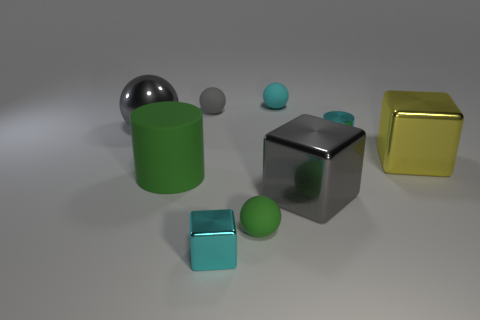There is a gray object that is both on the right side of the big green object and behind the yellow shiny cube; what is it made of?
Your answer should be very brief. Rubber. Is the number of cylinders behind the green cylinder greater than the number of big green things that are on the left side of the large gray ball?
Your response must be concise. Yes. Is there a matte cylinder of the same size as the gray shiny block?
Ensure brevity in your answer.  Yes. There is a cylinder to the right of the big block in front of the cube on the right side of the gray shiny block; how big is it?
Give a very brief answer. Small. The large matte cylinder has what color?
Keep it short and to the point. Green. Is the number of small green rubber spheres on the left side of the gray shiny ball greater than the number of small brown cylinders?
Keep it short and to the point. No. There is a gray block; how many large gray blocks are behind it?
Give a very brief answer. 0. There is a small object that is the same color as the large ball; what shape is it?
Offer a very short reply. Sphere. There is a large gray object on the right side of the cyan object that is behind the gray metallic ball; is there a tiny cyan thing left of it?
Offer a terse response. Yes. Do the cyan rubber sphere and the gray metal cube have the same size?
Your response must be concise. No. 